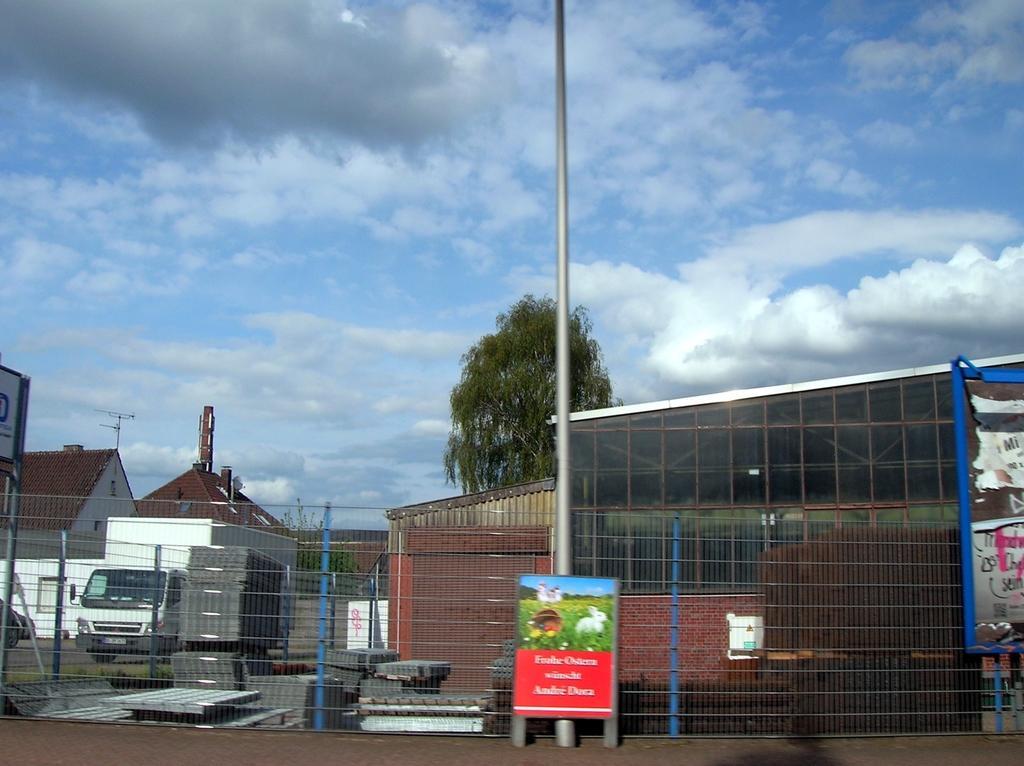In one or two sentences, can you explain what this image depicts? There is a poster, pole and net fencing in the foreground, there are shelters, it seems like metal sheets, houses, trees, vehicle and sky in the background area. 